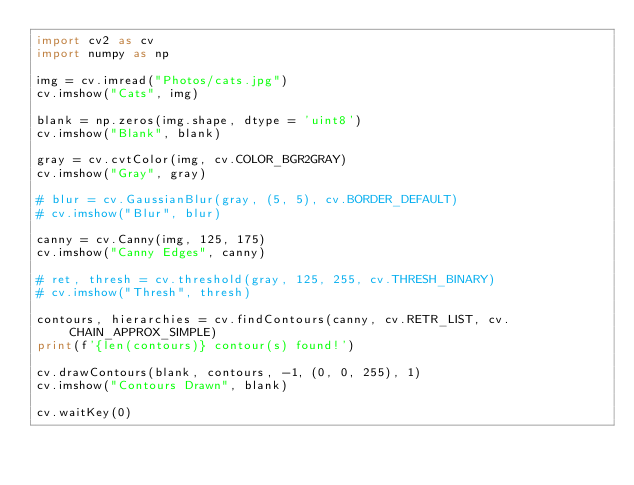Convert code to text. <code><loc_0><loc_0><loc_500><loc_500><_Python_>import cv2 as cv
import numpy as np

img = cv.imread("Photos/cats.jpg")
cv.imshow("Cats", img)

blank = np.zeros(img.shape, dtype = 'uint8')
cv.imshow("Blank", blank)

gray = cv.cvtColor(img, cv.COLOR_BGR2GRAY)
cv.imshow("Gray", gray)

# blur = cv.GaussianBlur(gray, (5, 5), cv.BORDER_DEFAULT)
# cv.imshow("Blur", blur)

canny = cv.Canny(img, 125, 175)
cv.imshow("Canny Edges", canny)

# ret, thresh = cv.threshold(gray, 125, 255, cv.THRESH_BINARY)
# cv.imshow("Thresh", thresh)

contours, hierarchies = cv.findContours(canny, cv.RETR_LIST, cv.CHAIN_APPROX_SIMPLE)
print(f'{len(contours)} contour(s) found!')

cv.drawContours(blank, contours, -1, (0, 0, 255), 1)
cv.imshow("Contours Drawn", blank)

cv.waitKey(0)</code> 